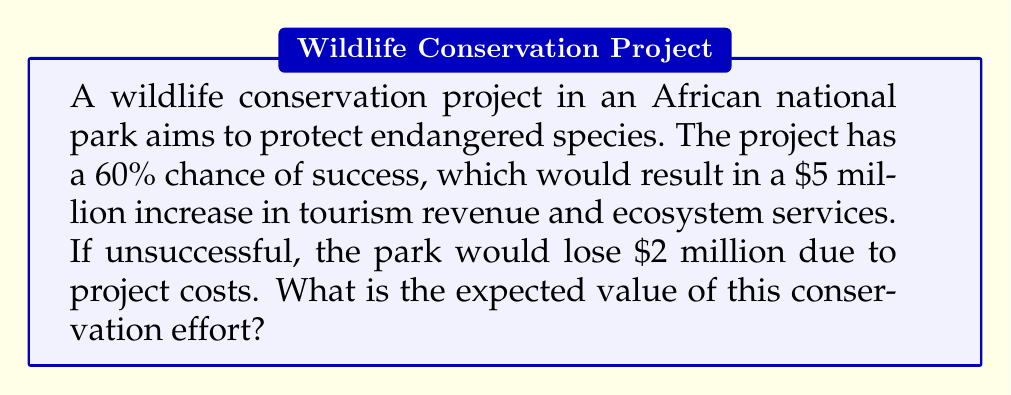Can you solve this math problem? To calculate the expected value, we need to consider both possible outcomes and their probabilities:

1. Success scenario:
   - Probability: $p = 0.60$ (60%)
   - Value: $v_1 = \$5,000,000$

2. Failure scenario:
   - Probability: $1 - p = 0.40$ (40%)
   - Value: $v_2 = -\$2,000,000$

The expected value (EV) is calculated using the formula:

$$EV = p \cdot v_1 + (1-p) \cdot v_2$$

Let's substitute the values:

$$\begin{align}
EV &= 0.60 \cdot \$5,000,000 + 0.40 \cdot (-\$2,000,000) \\
&= \$3,000,000 - \$800,000 \\
&= \$2,200,000
\end{align}$$

Therefore, the expected value of the wildlife conservation effort is $2,200,000.
Answer: $2,200,000 